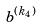Convert formula to latex. <formula><loc_0><loc_0><loc_500><loc_500>b ^ { ( k _ { 4 } ) }</formula> 